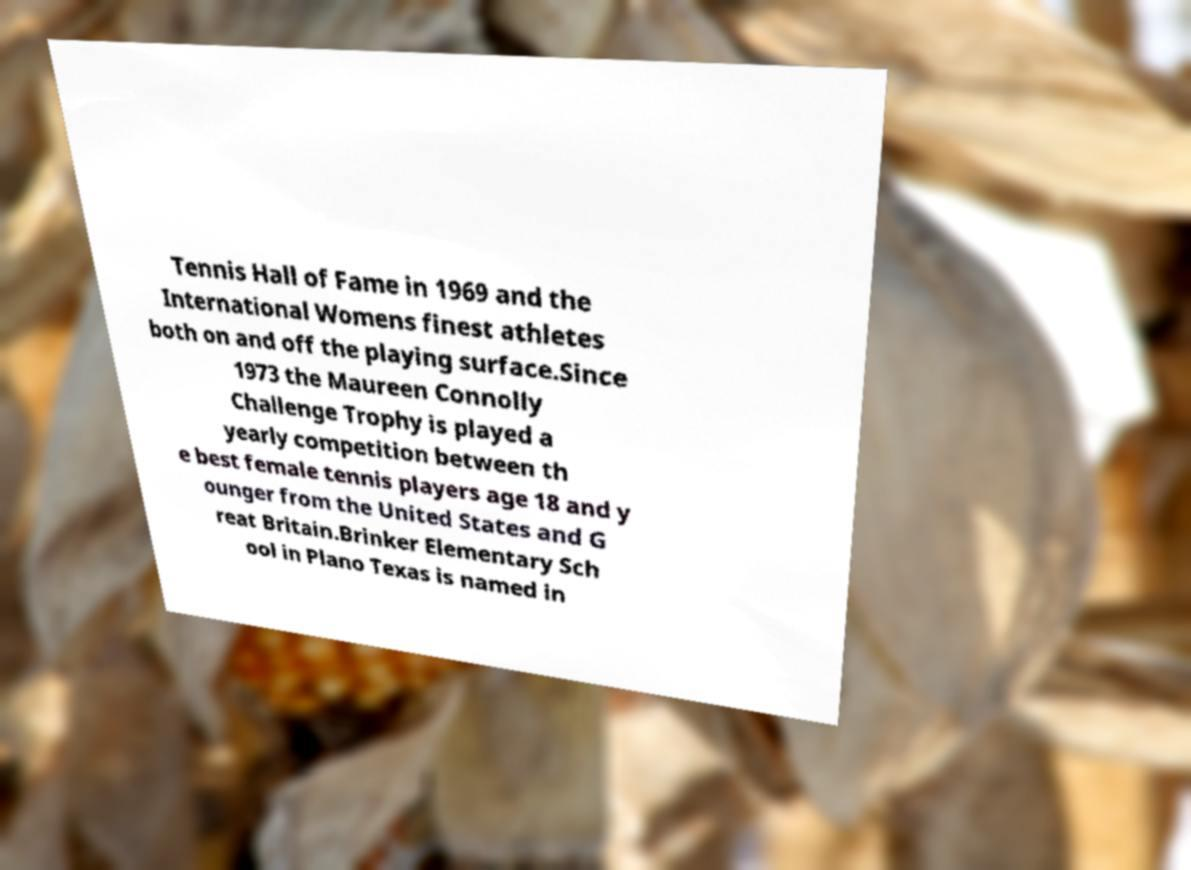Can you accurately transcribe the text from the provided image for me? Tennis Hall of Fame in 1969 and the International Womens finest athletes both on and off the playing surface.Since 1973 the Maureen Connolly Challenge Trophy is played a yearly competition between th e best female tennis players age 18 and y ounger from the United States and G reat Britain.Brinker Elementary Sch ool in Plano Texas is named in 